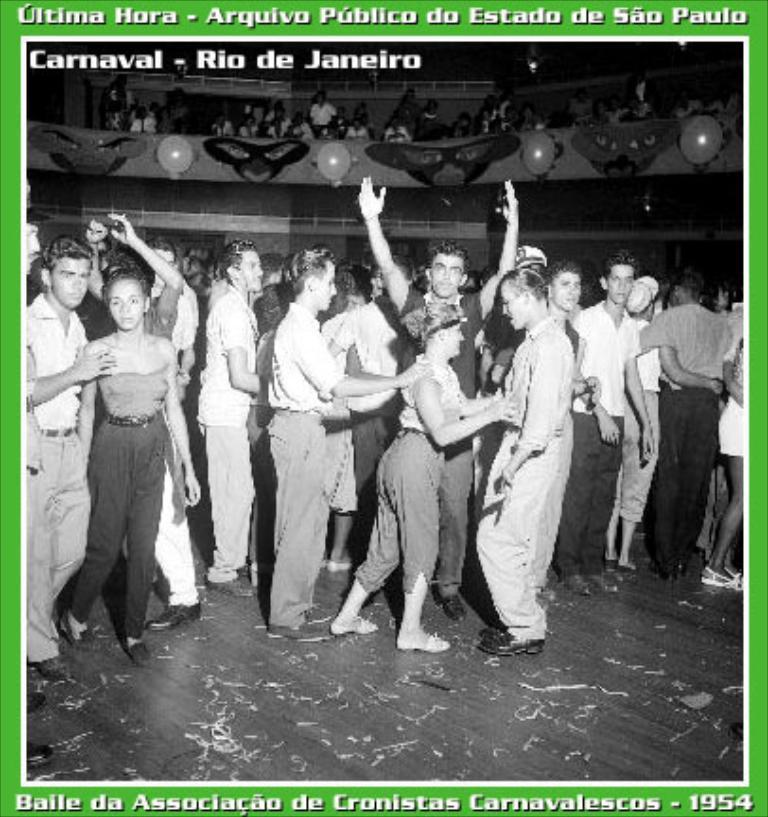How would you summarize this image in a sentence or two? This is a black and white image and it is edited. Here I can see a crowd of people standing on the floor and few people are dancing. In the background there is a wall and also there are few people in the dark. At the top and bottom of the image I can see some text. 